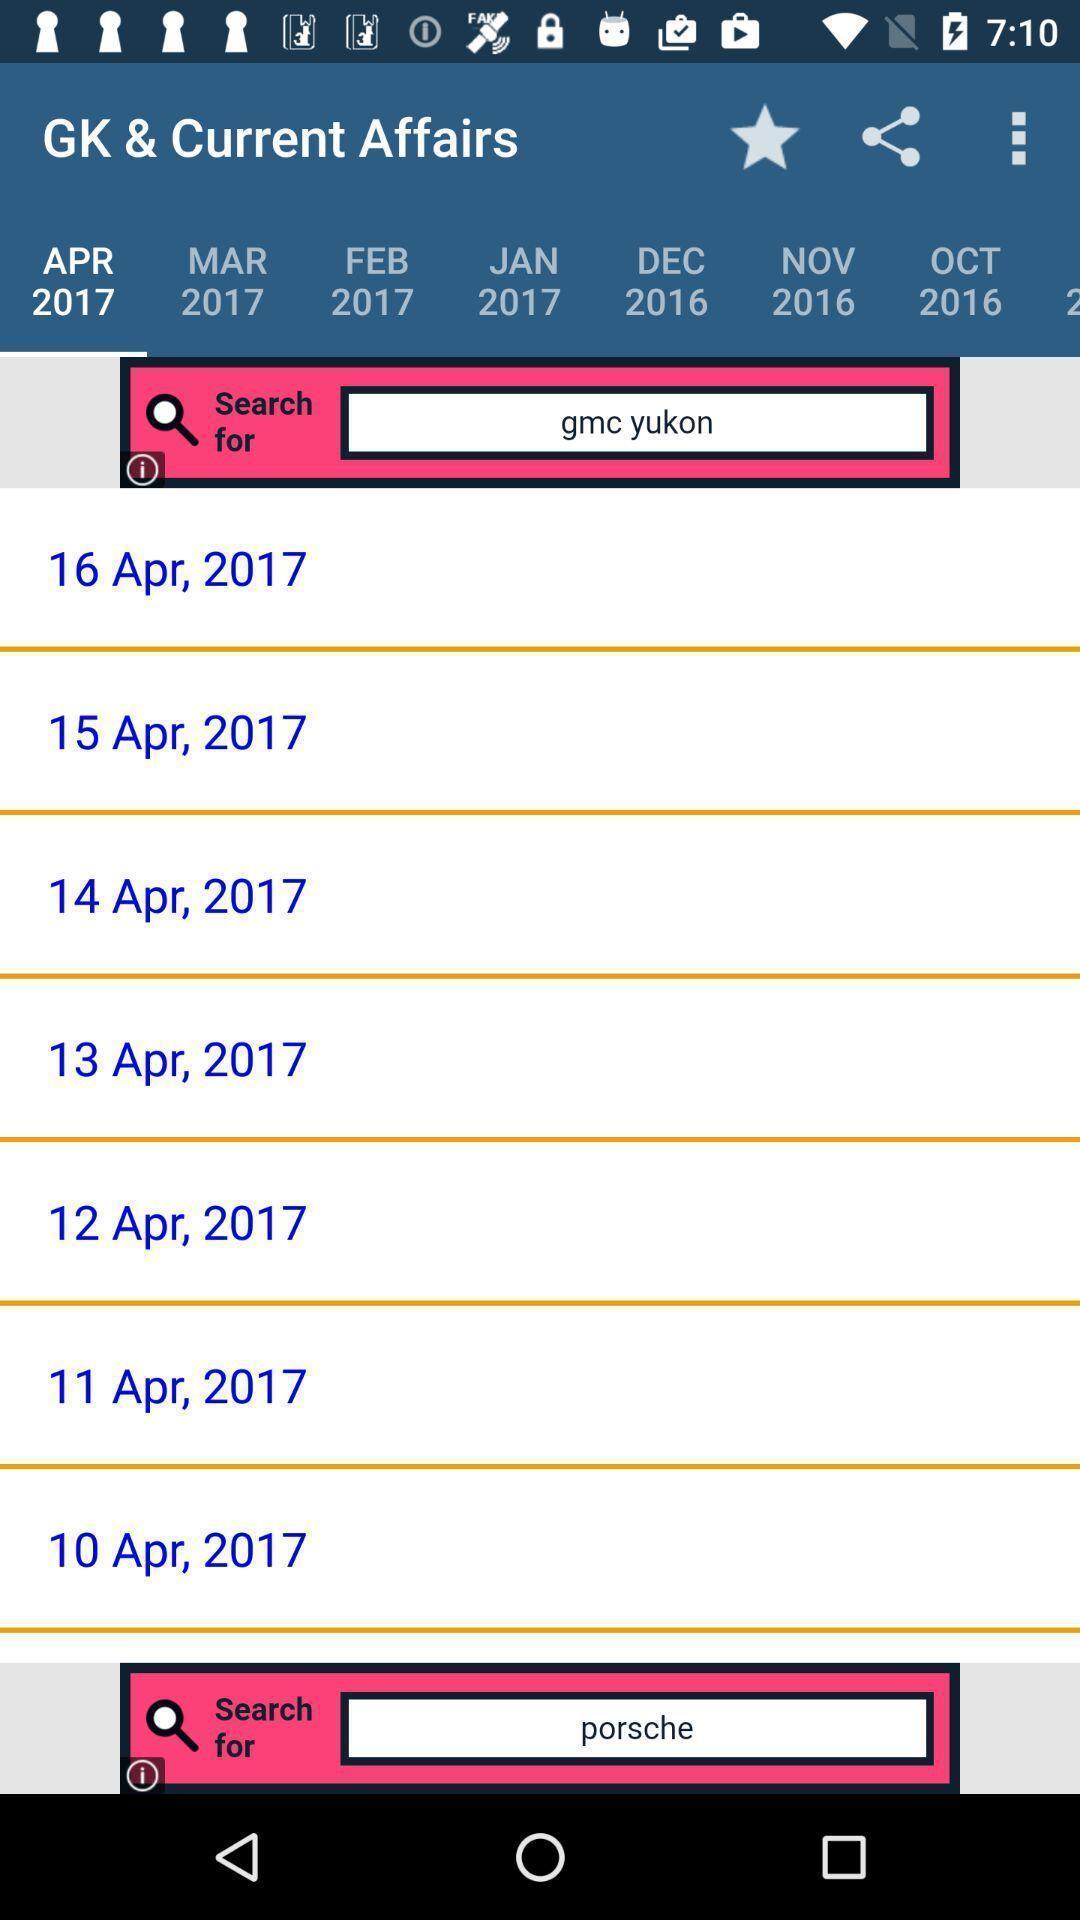Describe the content in this image. Page showing various months for general knowledge app. 